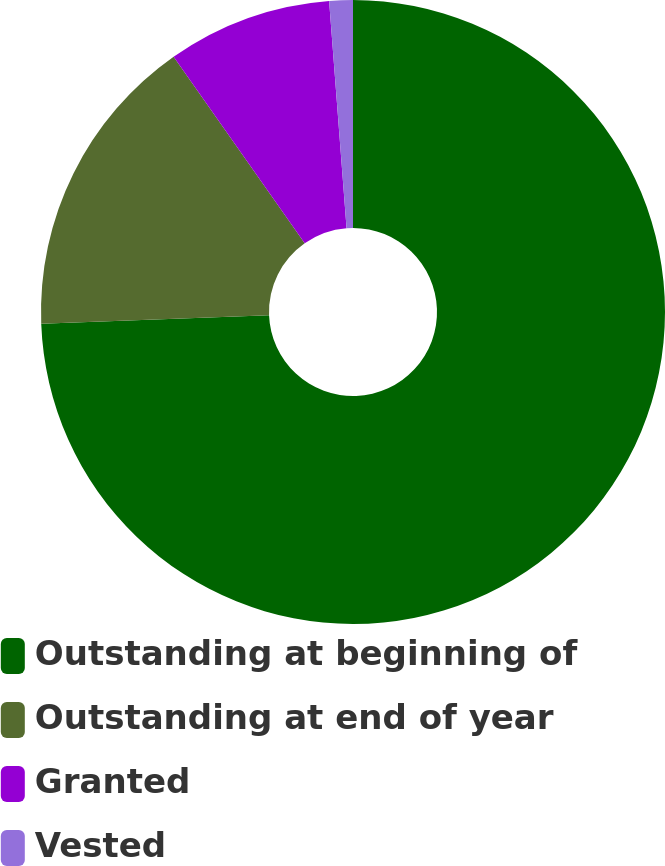Convert chart to OTSL. <chart><loc_0><loc_0><loc_500><loc_500><pie_chart><fcel>Outstanding at beginning of<fcel>Outstanding at end of year<fcel>Granted<fcel>Vested<nl><fcel>74.4%<fcel>15.85%<fcel>8.53%<fcel>1.22%<nl></chart> 